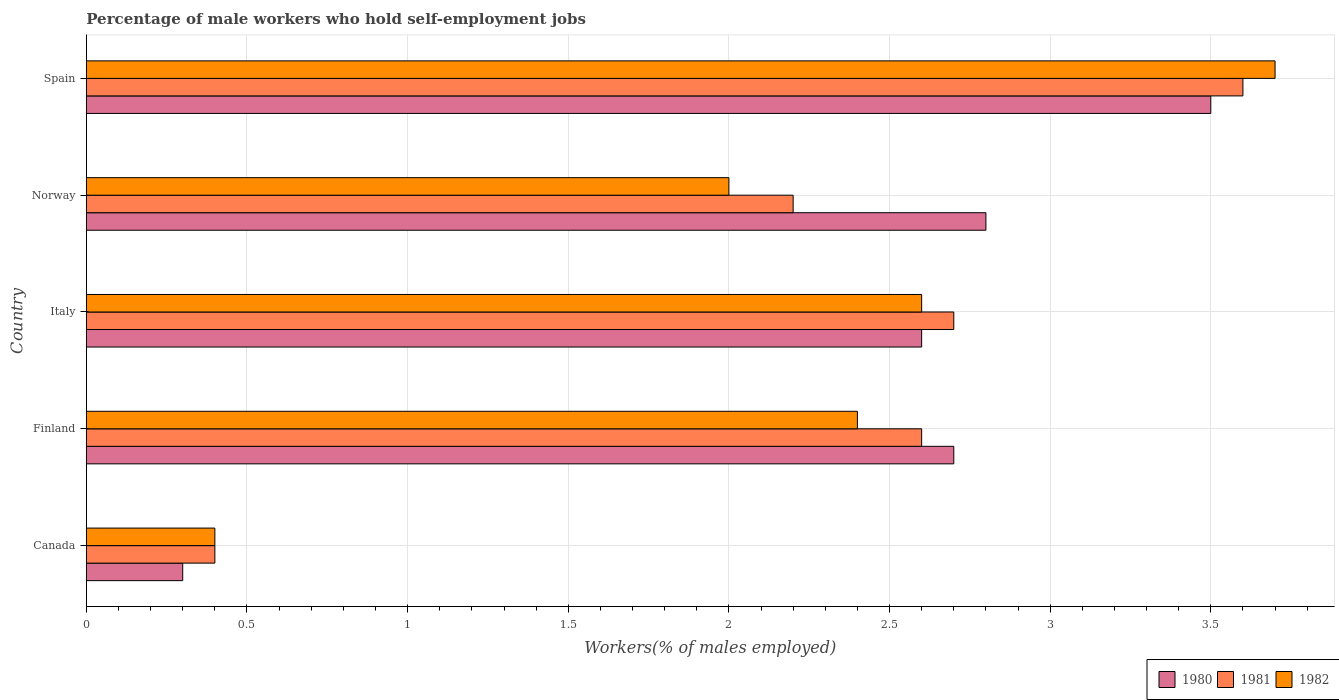How many different coloured bars are there?
Offer a very short reply. 3. What is the label of the 4th group of bars from the top?
Ensure brevity in your answer.  Finland. What is the percentage of self-employed male workers in 1982 in Italy?
Keep it short and to the point. 2.6. Across all countries, what is the maximum percentage of self-employed male workers in 1981?
Provide a succinct answer. 3.6. Across all countries, what is the minimum percentage of self-employed male workers in 1982?
Ensure brevity in your answer.  0.4. In which country was the percentage of self-employed male workers in 1981 maximum?
Your response must be concise. Spain. In which country was the percentage of self-employed male workers in 1980 minimum?
Your response must be concise. Canada. What is the total percentage of self-employed male workers in 1982 in the graph?
Keep it short and to the point. 11.1. What is the difference between the percentage of self-employed male workers in 1982 in Finland and that in Italy?
Make the answer very short. -0.2. What is the difference between the percentage of self-employed male workers in 1980 in Spain and the percentage of self-employed male workers in 1982 in Canada?
Keep it short and to the point. 3.1. What is the average percentage of self-employed male workers in 1981 per country?
Offer a very short reply. 2.3. What is the difference between the percentage of self-employed male workers in 1982 and percentage of self-employed male workers in 1980 in Finland?
Provide a succinct answer. -0.3. In how many countries, is the percentage of self-employed male workers in 1980 greater than 3.3 %?
Offer a very short reply. 1. What is the ratio of the percentage of self-employed male workers in 1982 in Canada to that in Spain?
Offer a very short reply. 0.11. Is the difference between the percentage of self-employed male workers in 1982 in Finland and Italy greater than the difference between the percentage of self-employed male workers in 1980 in Finland and Italy?
Your answer should be very brief. No. What is the difference between the highest and the second highest percentage of self-employed male workers in 1981?
Ensure brevity in your answer.  0.9. What is the difference between the highest and the lowest percentage of self-employed male workers in 1982?
Ensure brevity in your answer.  3.3. What does the 2nd bar from the top in Canada represents?
Your response must be concise. 1981. What does the 1st bar from the bottom in Finland represents?
Your answer should be compact. 1980. Is it the case that in every country, the sum of the percentage of self-employed male workers in 1982 and percentage of self-employed male workers in 1980 is greater than the percentage of self-employed male workers in 1981?
Give a very brief answer. Yes. How many countries are there in the graph?
Offer a very short reply. 5. Where does the legend appear in the graph?
Your answer should be compact. Bottom right. How many legend labels are there?
Your response must be concise. 3. What is the title of the graph?
Provide a succinct answer. Percentage of male workers who hold self-employment jobs. Does "1971" appear as one of the legend labels in the graph?
Your response must be concise. No. What is the label or title of the X-axis?
Provide a short and direct response. Workers(% of males employed). What is the Workers(% of males employed) in 1980 in Canada?
Ensure brevity in your answer.  0.3. What is the Workers(% of males employed) in 1981 in Canada?
Give a very brief answer. 0.4. What is the Workers(% of males employed) in 1982 in Canada?
Provide a succinct answer. 0.4. What is the Workers(% of males employed) of 1980 in Finland?
Your response must be concise. 2.7. What is the Workers(% of males employed) of 1981 in Finland?
Offer a terse response. 2.6. What is the Workers(% of males employed) in 1982 in Finland?
Offer a very short reply. 2.4. What is the Workers(% of males employed) of 1980 in Italy?
Ensure brevity in your answer.  2.6. What is the Workers(% of males employed) of 1981 in Italy?
Provide a short and direct response. 2.7. What is the Workers(% of males employed) in 1982 in Italy?
Provide a succinct answer. 2.6. What is the Workers(% of males employed) of 1980 in Norway?
Provide a succinct answer. 2.8. What is the Workers(% of males employed) of 1981 in Norway?
Make the answer very short. 2.2. What is the Workers(% of males employed) of 1981 in Spain?
Provide a succinct answer. 3.6. What is the Workers(% of males employed) of 1982 in Spain?
Give a very brief answer. 3.7. Across all countries, what is the maximum Workers(% of males employed) in 1981?
Ensure brevity in your answer.  3.6. Across all countries, what is the maximum Workers(% of males employed) of 1982?
Your answer should be very brief. 3.7. Across all countries, what is the minimum Workers(% of males employed) in 1980?
Offer a very short reply. 0.3. Across all countries, what is the minimum Workers(% of males employed) in 1981?
Make the answer very short. 0.4. Across all countries, what is the minimum Workers(% of males employed) in 1982?
Make the answer very short. 0.4. What is the total Workers(% of males employed) in 1981 in the graph?
Provide a succinct answer. 11.5. What is the total Workers(% of males employed) in 1982 in the graph?
Provide a short and direct response. 11.1. What is the difference between the Workers(% of males employed) of 1981 in Canada and that in Finland?
Your answer should be compact. -2.2. What is the difference between the Workers(% of males employed) of 1982 in Canada and that in Finland?
Offer a very short reply. -2. What is the difference between the Workers(% of males employed) in 1980 in Canada and that in Norway?
Provide a short and direct response. -2.5. What is the difference between the Workers(% of males employed) of 1982 in Canada and that in Spain?
Offer a very short reply. -3.3. What is the difference between the Workers(% of males employed) in 1980 in Finland and that in Italy?
Your answer should be very brief. 0.1. What is the difference between the Workers(% of males employed) in 1981 in Finland and that in Italy?
Your answer should be very brief. -0.1. What is the difference between the Workers(% of males employed) of 1982 in Finland and that in Italy?
Offer a terse response. -0.2. What is the difference between the Workers(% of males employed) in 1981 in Finland and that in Norway?
Your answer should be compact. 0.4. What is the difference between the Workers(% of males employed) in 1982 in Finland and that in Norway?
Keep it short and to the point. 0.4. What is the difference between the Workers(% of males employed) in 1980 in Finland and that in Spain?
Your answer should be compact. -0.8. What is the difference between the Workers(% of males employed) of 1981 in Finland and that in Spain?
Provide a succinct answer. -1. What is the difference between the Workers(% of males employed) of 1981 in Italy and that in Norway?
Make the answer very short. 0.5. What is the difference between the Workers(% of males employed) in 1982 in Italy and that in Spain?
Ensure brevity in your answer.  -1.1. What is the difference between the Workers(% of males employed) of 1980 in Norway and that in Spain?
Your response must be concise. -0.7. What is the difference between the Workers(% of males employed) of 1981 in Norway and that in Spain?
Make the answer very short. -1.4. What is the difference between the Workers(% of males employed) of 1982 in Norway and that in Spain?
Make the answer very short. -1.7. What is the difference between the Workers(% of males employed) of 1980 in Canada and the Workers(% of males employed) of 1981 in Finland?
Make the answer very short. -2.3. What is the difference between the Workers(% of males employed) in 1980 in Canada and the Workers(% of males employed) in 1981 in Norway?
Give a very brief answer. -1.9. What is the difference between the Workers(% of males employed) of 1981 in Canada and the Workers(% of males employed) of 1982 in Norway?
Give a very brief answer. -1.6. What is the difference between the Workers(% of males employed) of 1980 in Canada and the Workers(% of males employed) of 1981 in Spain?
Your response must be concise. -3.3. What is the difference between the Workers(% of males employed) of 1980 in Canada and the Workers(% of males employed) of 1982 in Spain?
Offer a terse response. -3.4. What is the difference between the Workers(% of males employed) of 1980 in Finland and the Workers(% of males employed) of 1982 in Italy?
Make the answer very short. 0.1. What is the difference between the Workers(% of males employed) of 1981 in Finland and the Workers(% of males employed) of 1982 in Italy?
Offer a very short reply. 0. What is the difference between the Workers(% of males employed) in 1980 in Finland and the Workers(% of males employed) in 1981 in Norway?
Give a very brief answer. 0.5. What is the difference between the Workers(% of males employed) of 1980 in Finland and the Workers(% of males employed) of 1982 in Norway?
Ensure brevity in your answer.  0.7. What is the difference between the Workers(% of males employed) in 1980 in Finland and the Workers(% of males employed) in 1982 in Spain?
Offer a terse response. -1. What is the difference between the Workers(% of males employed) in 1981 in Finland and the Workers(% of males employed) in 1982 in Spain?
Provide a short and direct response. -1.1. What is the difference between the Workers(% of males employed) of 1981 in Italy and the Workers(% of males employed) of 1982 in Norway?
Provide a succinct answer. 0.7. What is the difference between the Workers(% of males employed) of 1980 in Italy and the Workers(% of males employed) of 1981 in Spain?
Offer a terse response. -1. What is the difference between the Workers(% of males employed) of 1980 in Italy and the Workers(% of males employed) of 1982 in Spain?
Give a very brief answer. -1.1. What is the difference between the Workers(% of males employed) of 1980 in Norway and the Workers(% of males employed) of 1981 in Spain?
Make the answer very short. -0.8. What is the difference between the Workers(% of males employed) of 1981 in Norway and the Workers(% of males employed) of 1982 in Spain?
Your answer should be compact. -1.5. What is the average Workers(% of males employed) of 1980 per country?
Ensure brevity in your answer.  2.38. What is the average Workers(% of males employed) in 1982 per country?
Give a very brief answer. 2.22. What is the difference between the Workers(% of males employed) of 1980 and Workers(% of males employed) of 1981 in Canada?
Your answer should be compact. -0.1. What is the difference between the Workers(% of males employed) in 1980 and Workers(% of males employed) in 1982 in Canada?
Your response must be concise. -0.1. What is the difference between the Workers(% of males employed) of 1980 and Workers(% of males employed) of 1981 in Norway?
Keep it short and to the point. 0.6. What is the difference between the Workers(% of males employed) in 1980 and Workers(% of males employed) in 1982 in Norway?
Your answer should be compact. 0.8. What is the ratio of the Workers(% of males employed) of 1981 in Canada to that in Finland?
Offer a terse response. 0.15. What is the ratio of the Workers(% of males employed) in 1980 in Canada to that in Italy?
Offer a terse response. 0.12. What is the ratio of the Workers(% of males employed) of 1981 in Canada to that in Italy?
Provide a short and direct response. 0.15. What is the ratio of the Workers(% of males employed) in 1982 in Canada to that in Italy?
Provide a short and direct response. 0.15. What is the ratio of the Workers(% of males employed) of 1980 in Canada to that in Norway?
Provide a succinct answer. 0.11. What is the ratio of the Workers(% of males employed) of 1981 in Canada to that in Norway?
Ensure brevity in your answer.  0.18. What is the ratio of the Workers(% of males employed) in 1982 in Canada to that in Norway?
Make the answer very short. 0.2. What is the ratio of the Workers(% of males employed) of 1980 in Canada to that in Spain?
Your answer should be very brief. 0.09. What is the ratio of the Workers(% of males employed) in 1982 in Canada to that in Spain?
Provide a short and direct response. 0.11. What is the ratio of the Workers(% of males employed) of 1980 in Finland to that in Italy?
Give a very brief answer. 1.04. What is the ratio of the Workers(% of males employed) in 1982 in Finland to that in Italy?
Your answer should be very brief. 0.92. What is the ratio of the Workers(% of males employed) of 1981 in Finland to that in Norway?
Offer a terse response. 1.18. What is the ratio of the Workers(% of males employed) of 1980 in Finland to that in Spain?
Give a very brief answer. 0.77. What is the ratio of the Workers(% of males employed) of 1981 in Finland to that in Spain?
Offer a terse response. 0.72. What is the ratio of the Workers(% of males employed) of 1982 in Finland to that in Spain?
Your answer should be compact. 0.65. What is the ratio of the Workers(% of males employed) in 1980 in Italy to that in Norway?
Make the answer very short. 0.93. What is the ratio of the Workers(% of males employed) in 1981 in Italy to that in Norway?
Your answer should be very brief. 1.23. What is the ratio of the Workers(% of males employed) in 1980 in Italy to that in Spain?
Make the answer very short. 0.74. What is the ratio of the Workers(% of males employed) in 1982 in Italy to that in Spain?
Make the answer very short. 0.7. What is the ratio of the Workers(% of males employed) of 1980 in Norway to that in Spain?
Your answer should be very brief. 0.8. What is the ratio of the Workers(% of males employed) in 1981 in Norway to that in Spain?
Give a very brief answer. 0.61. What is the ratio of the Workers(% of males employed) of 1982 in Norway to that in Spain?
Make the answer very short. 0.54. What is the difference between the highest and the second highest Workers(% of males employed) of 1980?
Offer a very short reply. 0.7. What is the difference between the highest and the lowest Workers(% of males employed) in 1982?
Provide a succinct answer. 3.3. 